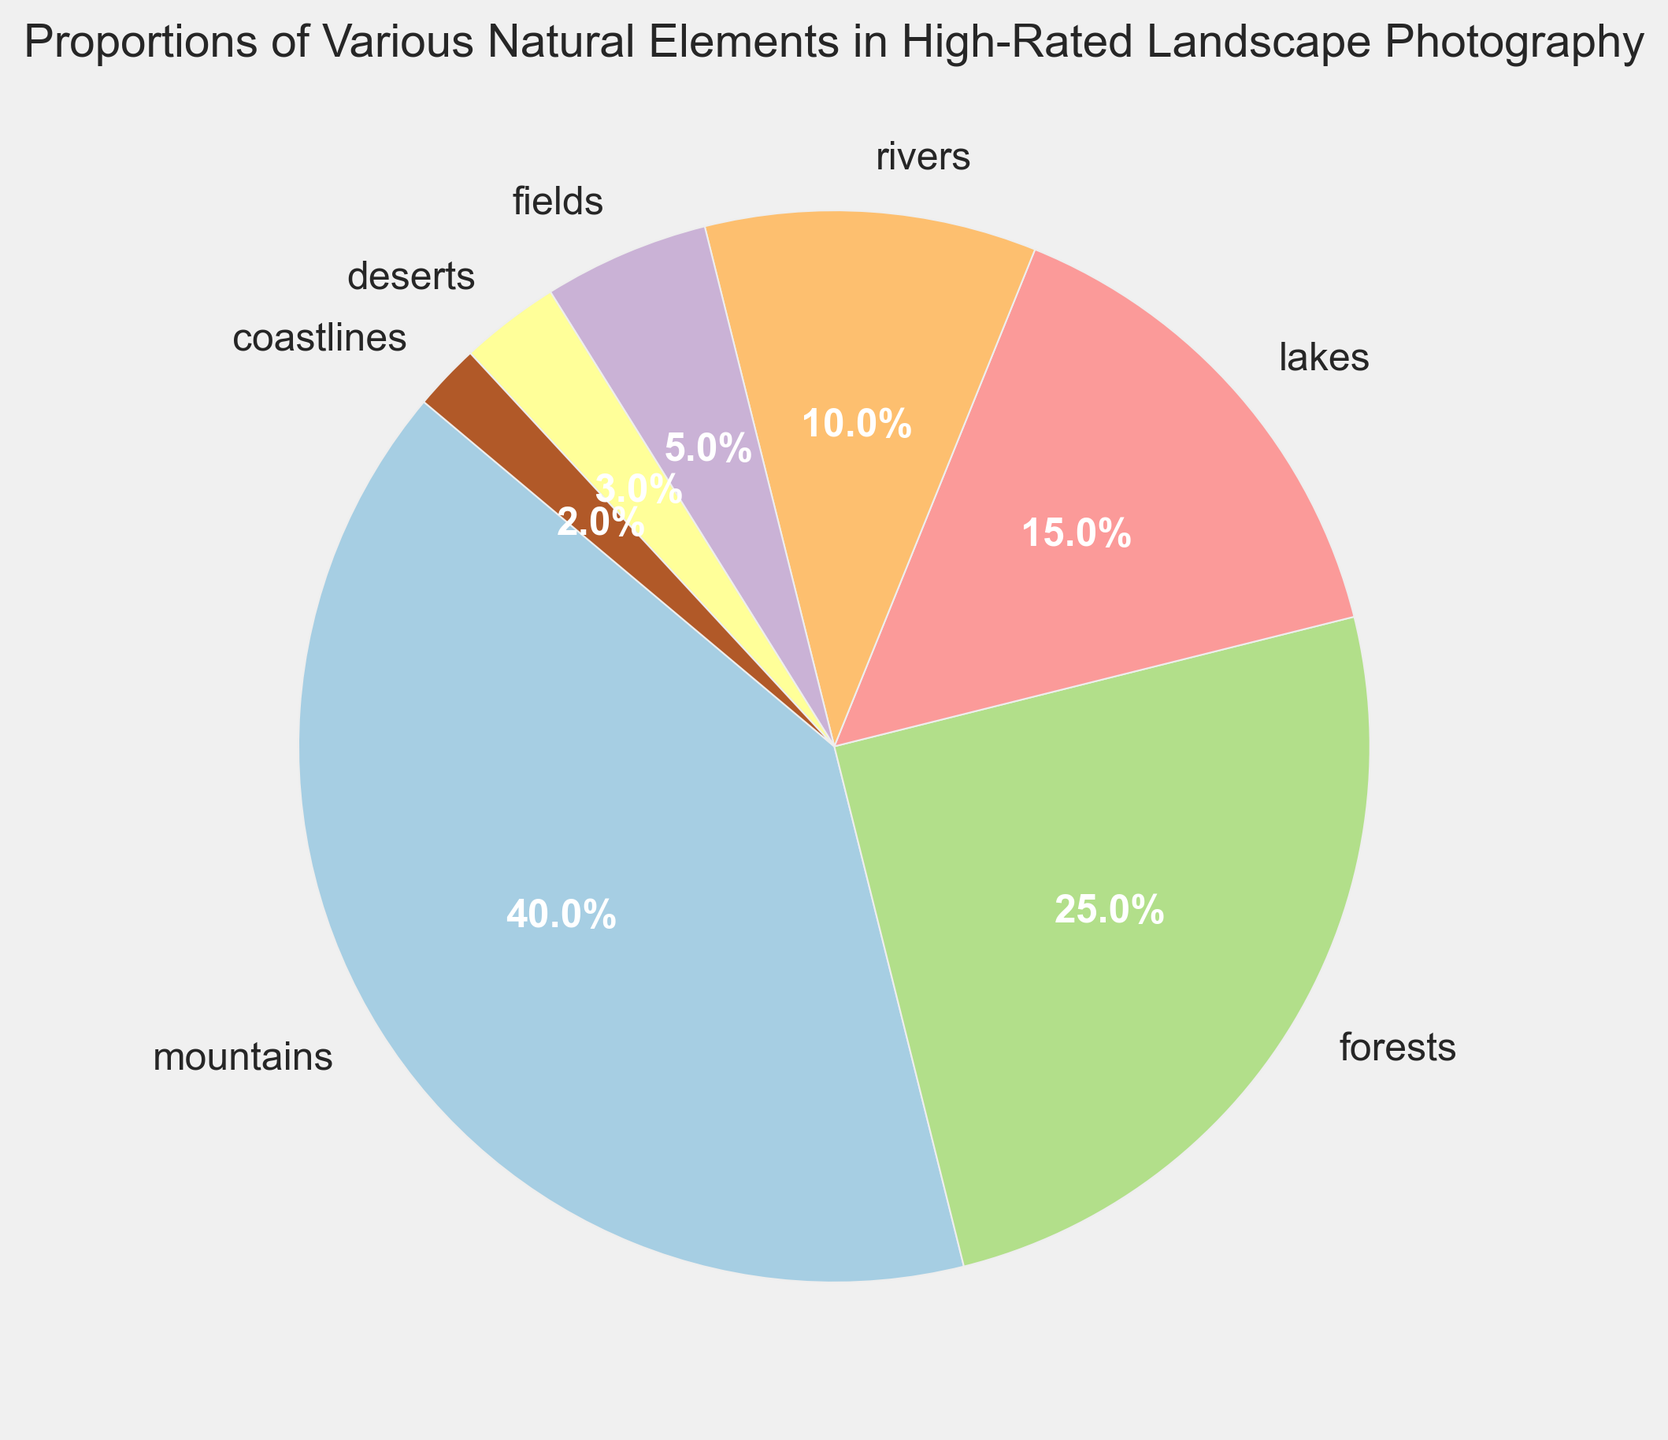Which natural element has the highest proportion in high-rated landscape photography? By examining the pie chart, we see that the segment representing mountains is the largest, with a value of 40%. Therefore, mountains have the highest proportion.
Answer: Mountains What is the combined proportion of forests and lakes? To find the combined proportion, add the percentages of forests (25%) and lakes (15%): 25% + 15% = 40%.
Answer: 40% How does the proportion of rivers compare to that of deserts? By looking at the pie chart, we can see that rivers have a proportion of 10%, while deserts have a proportion of 3%. Therefore, rivers have a higher proportion than deserts.
Answer: Rivers have a higher proportion Which natural element occupies the smallest proportion of high-rated landscape photography? By examining the pie chart, the segment representing coastlines is the smallest, with a proportion of 2%.
Answer: Coastlines What is the difference in proportion between mountains and forests? The given proportions are mountains (40%) and forests (25%). The difference is calculated as 40% - 25% = 15%.
Answer: 15% What is the total proportion of elements that each individually occupy less than 5%? The elements with less than 5% are fields (5%), deserts (3%), and coastlines (2%). The total is calculated as 5% + 3% + 2% = 10%.
Answer: 10% How does the proportion of lakes relate to the combined proportion of rivers and fields? The proportion of lakes is 15%. The combined proportion of rivers and fields is 10% (rivers) + 5% (fields) = 15%. Thus, both proportions are equal.
Answer: Equal What is the average proportion of the three elements with the lowest percentage? The three lowest percentages are deserts (3%), coastlines (2%), and fields (5%). Calculate the average: (3% + 2% + 5%) / 3 = 10% / 3 ≈ 3.33%.
Answer: 3.33% Which natural elements have more than double the proportion of deserts? Deserts have a proportion of 3%. Elements with more than double this proportion (i.e., > 6%) are mountains (40%), forests (25%), lakes (15%), and rivers (10%).
Answer: Mountains, forests, lakes, rivers What is the combined proportion of the elements that have a proportion lower than that of lakes? The elements with proportions lower than lakes (15%) are rivers (10%), fields (5%), deserts (3%), and coastlines (2%). The combined proportion is 10% + 5% + 3% + 2% = 20%.
Answer: 20% 